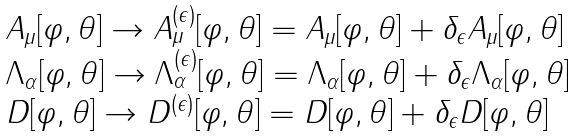Convert formula to latex. <formula><loc_0><loc_0><loc_500><loc_500>\begin{array} { l } { A _ { \mu } [ \varphi , \theta ] \rightarrow A _ { \mu } ^ { ( \epsilon ) } [ \varphi , \theta ] = A _ { \mu } [ \varphi , \theta ] + \delta _ { \epsilon } A _ { \mu } [ \varphi , \theta ] } \\ { \Lambda _ { \alpha } [ \varphi , \theta ] \rightarrow \Lambda _ { \alpha } ^ { ( \epsilon ) } [ \varphi , \theta ] = \Lambda _ { \alpha } [ \varphi , \theta ] + \delta _ { \epsilon } \Lambda _ { \alpha } [ \varphi , \theta ] } \\ { D [ \varphi , \theta ] \rightarrow D ^ { ( \epsilon ) } [ \varphi , \theta ] = D [ \varphi , \theta ] + \delta _ { \epsilon } D [ \varphi , \theta ] } \\ \end{array}</formula> 